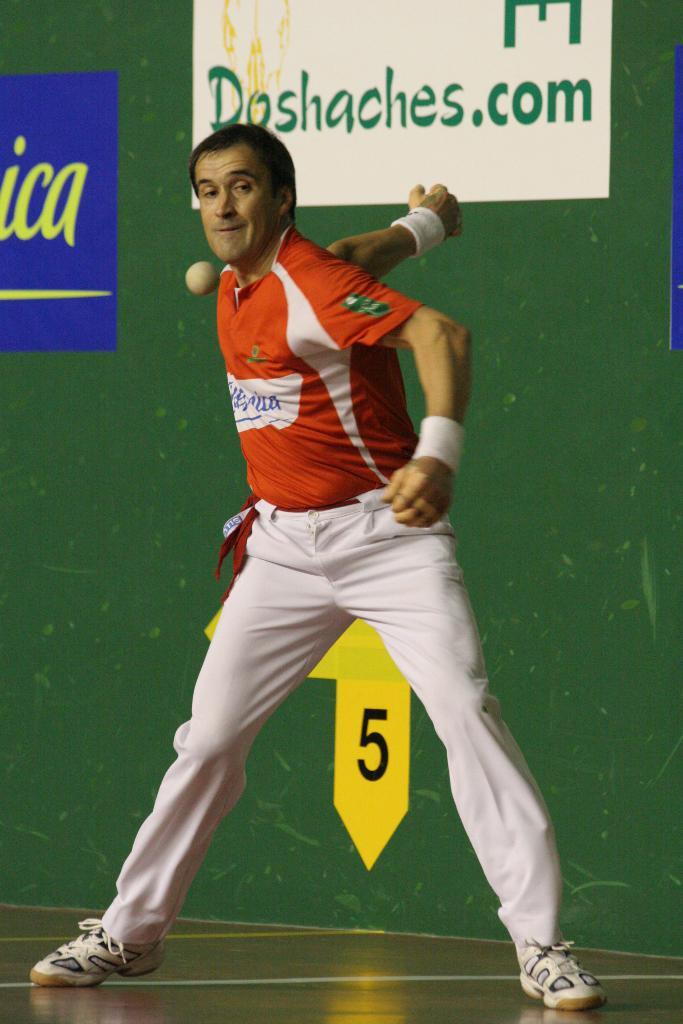What number is on the wall behind the mans legs?
Provide a short and direct response. 5. 